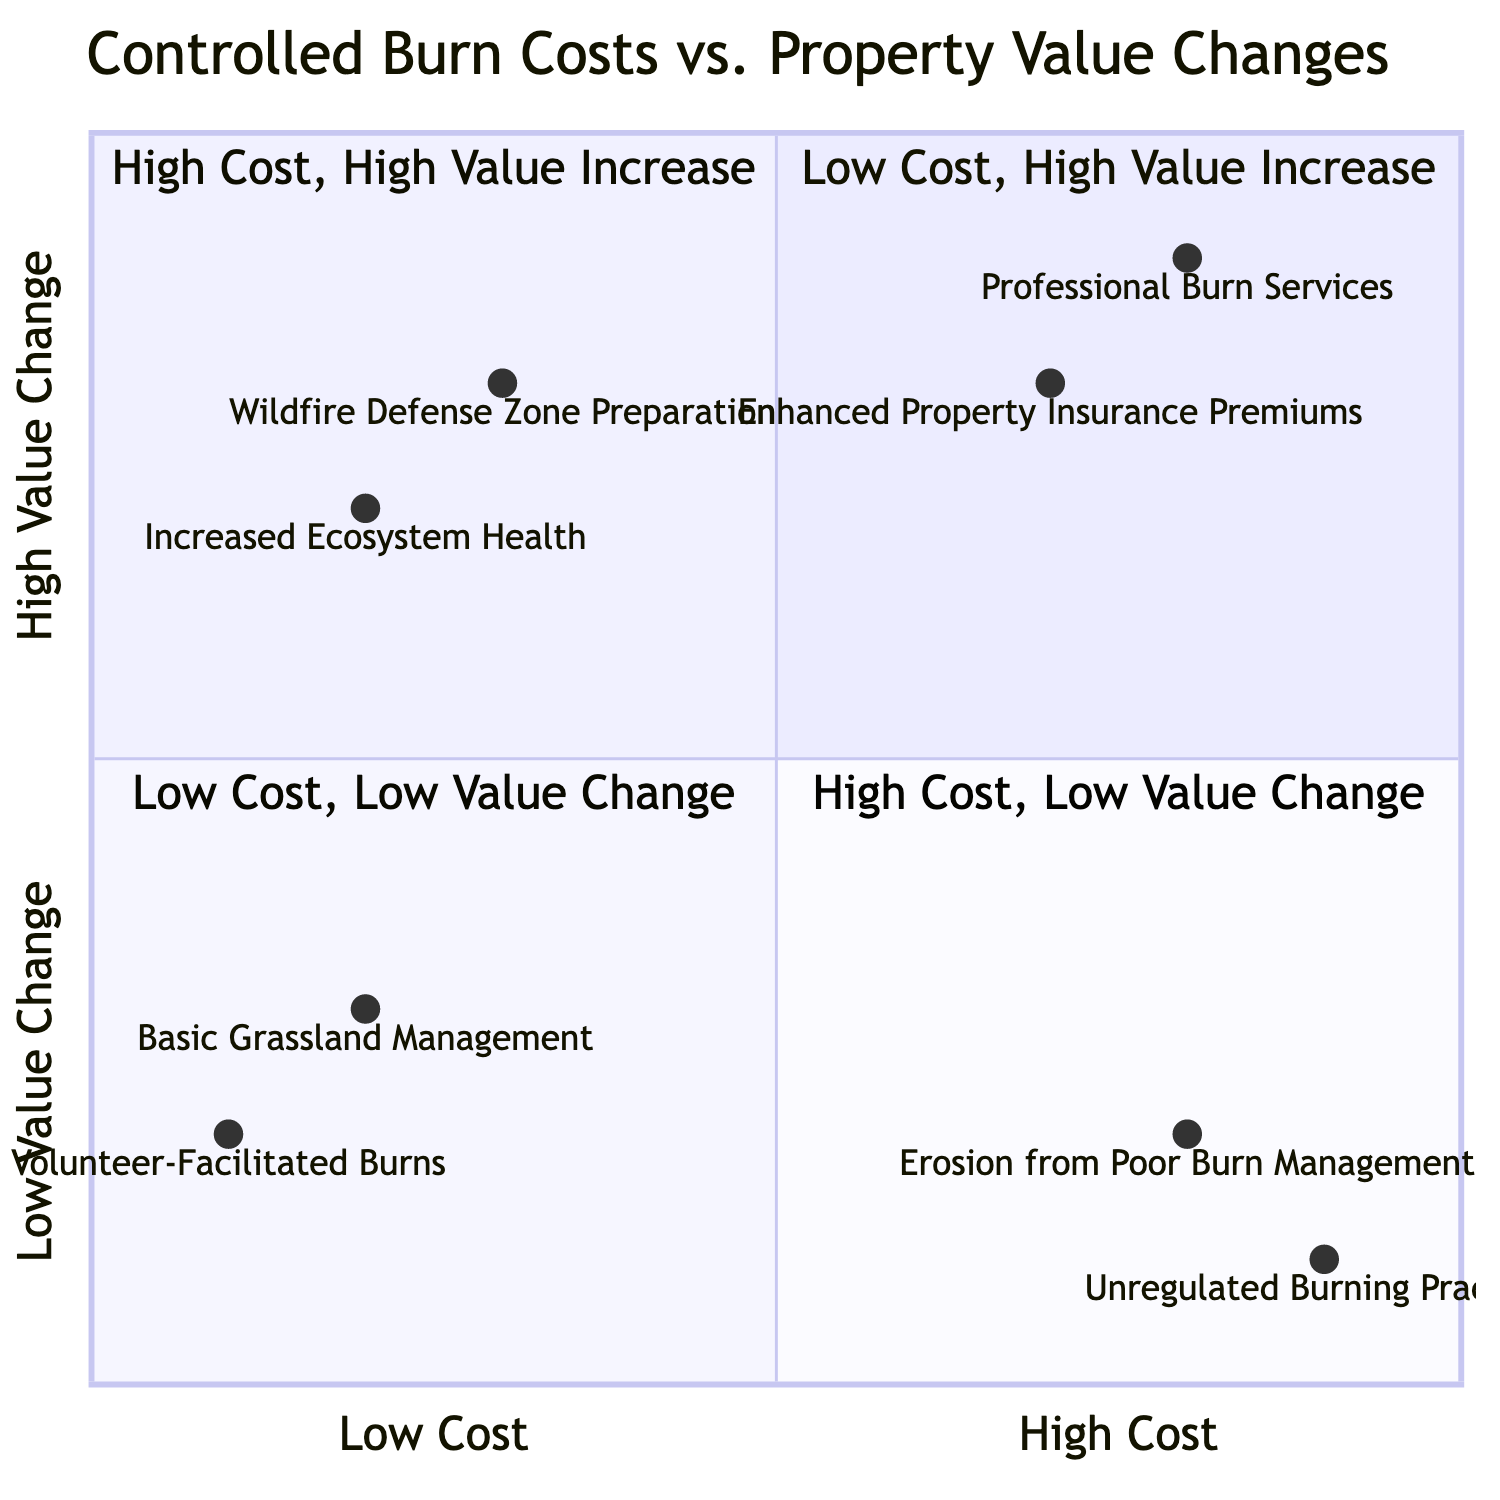What are the elements in the Low Cost, High Value Increase quadrant? The Low Cost, High Value Increase quadrant (Quadrant 1) contains two elements: "Wildfire Defense Zone Preparation" and "Increased Ecosystem Health".
Answer: Wildfire Defense Zone Preparation, Increased Ecosystem Health How many elements are in the High Cost, Low Value Change quadrant? The High Cost, Low Value Change quadrant (Quadrant 4) contains two elements: "Unregulated Burning Practices" and "Erosion from Poor Burn Management".
Answer: 2 Which element has the highest value increase associated with it? The element with the highest value increase in the chart is "Professional Burn Services" found in Quadrant 2.
Answer: Professional Burn Services What is the cost relationship between Professional Burn Services and Volunteer-Facilitated Burns? "Professional Burn Services" is categorized as High Cost and "Volunteer-Facilitated Burns" is categorized as Low Cost, indicating that professional services require a greater financial investment than volunteer efforts.
Answer: High Cost vs. Low Cost What quadrant contains elements that have both low cost and low value change? The elements with low cost and low value change are located in Quadrant 3.
Answer: Quadrant 3 Which element is associated with High Cost but Low Value Change? The element in the High Cost but Low Value Change quadrant (Quadrant 4) is "Unregulated Burning Practices".
Answer: Unregulated Burning Practices What is the general trend for elements classified in Quadrant 2? The general trend for elements in Quadrant 2 is that they involve higher costs and result in significant increases in property value.
Answer: High Cost, High Value Increase Which quadrant should a homeowner focus on for maximizing value with minimal investment? A homeowner should focus on Quadrant 1 for maximizing value with minimal investment, as it features low-cost options that yield high value increases.
Answer: Quadrant 1 How are Enhanced Property Insurance Premiums characterized in this diagram? "Enhanced Property Insurance Premiums" is characterized as a High Cost, High Value Increase element found in Quadrant 2.
Answer: High Cost, High Value Increase 